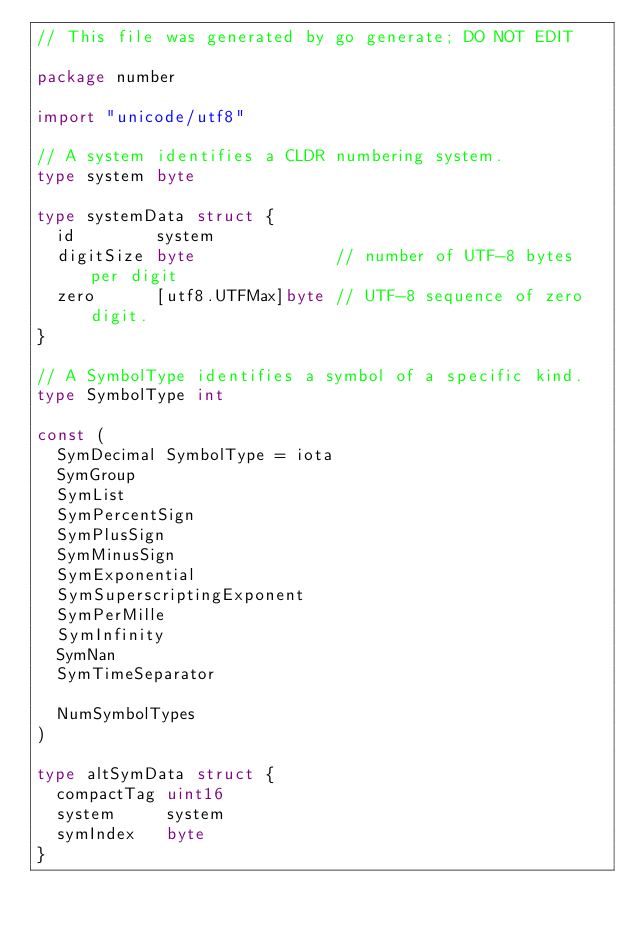Convert code to text. <code><loc_0><loc_0><loc_500><loc_500><_Go_>// This file was generated by go generate; DO NOT EDIT

package number

import "unicode/utf8"

// A system identifies a CLDR numbering system.
type system byte

type systemData struct {
	id        system
	digitSize byte              // number of UTF-8 bytes per digit
	zero      [utf8.UTFMax]byte // UTF-8 sequence of zero digit.
}

// A SymbolType identifies a symbol of a specific kind.
type SymbolType int

const (
	SymDecimal SymbolType = iota
	SymGroup
	SymList
	SymPercentSign
	SymPlusSign
	SymMinusSign
	SymExponential
	SymSuperscriptingExponent
	SymPerMille
	SymInfinity
	SymNan
	SymTimeSeparator

	NumSymbolTypes
)

type altSymData struct {
	compactTag uint16
	system     system
	symIndex   byte
}
</code> 